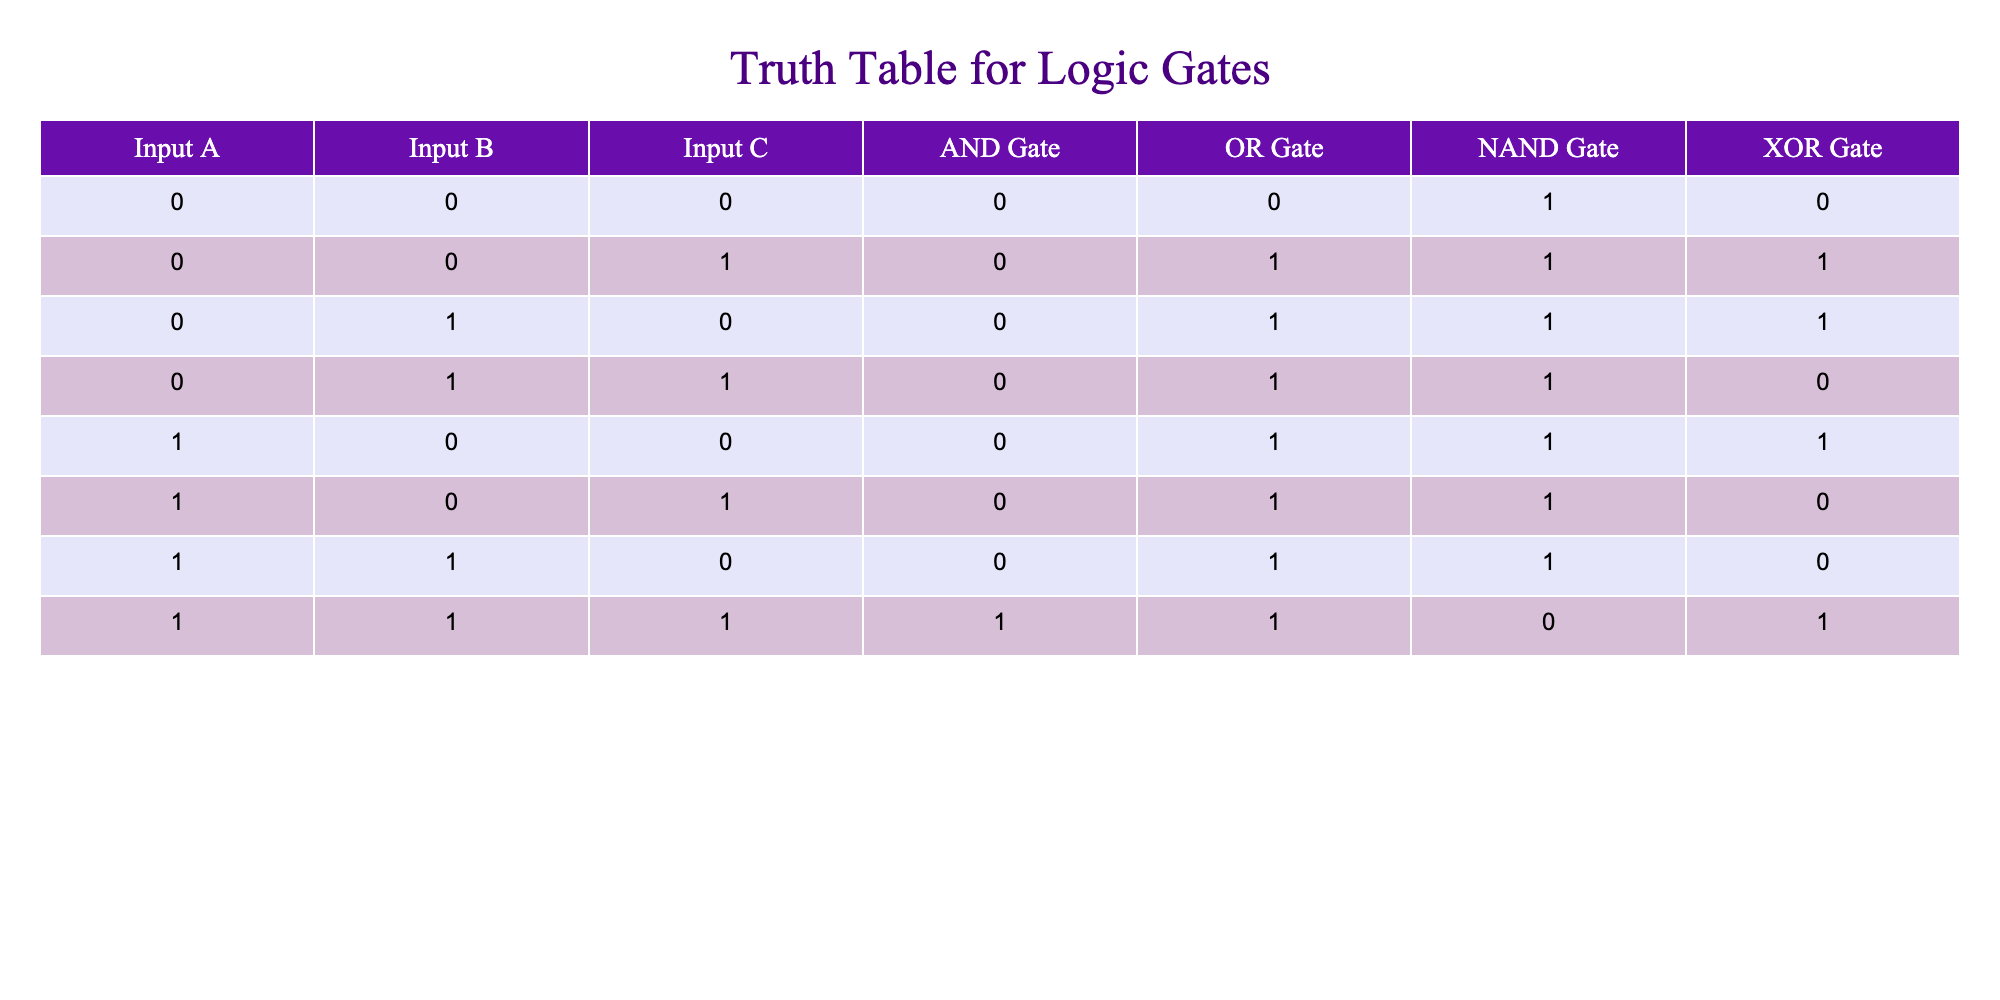What is the output of the AND gate when Input A, Input B, and Input C are all 1? According to the table, when Input A = 1, Input B = 1, and Input C = 1, the output of the AND gate is 1.
Answer: 1 What is the output of the XOR gate when Input A is 0, Input B is 1, and Input C is 0? In this case, Input A = 0 and Input B = 1 correspond to the row in the table where the XOR gate output is 1.
Answer: 1 Is the output of the NAND gate always the opposite of the AND gate? To determine this, look at the outputs of the AND and NAND gates for the same inputs. The outputs for 1, 1, 1 are 1 for AND and 0 for NAND, showing they are opposites only in that case, not universally.
Answer: No What is the maximum output value for the OR gate in this table? By examining the OR gate outputs across all rows in the table, the highest output value is found to be 1, occurring in multiple instances.
Answer: 1 How many times does the output of the NAND gate show a value of 1? Reviewing the NAND gate column, the output is 1 for inputs (0,0,0), (0,0,1), (0,1,0), (0,1,1), (1,0,0), (1,0,1), and (1,1,0), which totals 7 occurrences.
Answer: 7 What is the sum of the outputs of the AND gate across all input combinations? The outputs of the AND gate are 0 for 6 rows and 1 for 1 row, so the sum totals 0 + 0 + 0 + 0 + 0 + 0 + 1 = 1.
Answer: 1 Is there any combination where the output of the XOR gate is 0? Looking at the XOR gate outputs, the only combinations where the output is 0 occur when both inputs A and B are the same, confirming at least one case, specifically (0,0), (1,1,1).
Answer: Yes What is the output of both the OR gate and the NAND gate when Input A = 1, Input B = 0, and Input C = 1? For this input combination, the OR gate output is 1 and the NAND gate output is 0. Therefore, both outputs are identified: OR=1, NAND=0.
Answer: OR=1, NAND=0 What logic gate will produce a value of 0 when Input A = 1, Input B = 1, and Input C is any value? For this input setup, the AND gate, NAND gate, and the XOR gate will all produce an output of 0 since the AND gate outputs 1 only if all inputs are 1, while NAND produces 0 with inputs A and B as 1, regardless of C.
Answer: AND, NAND, XOR 